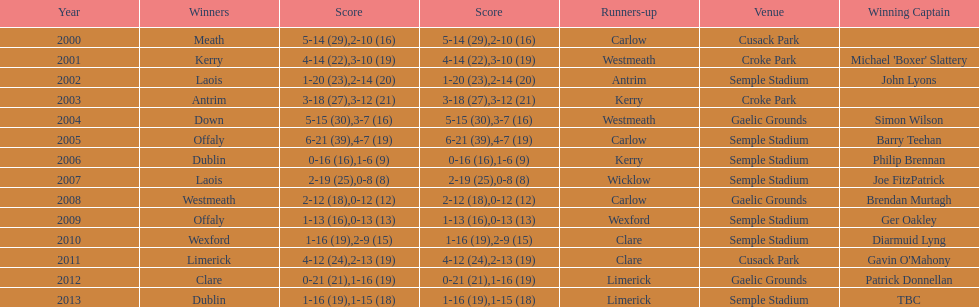Who was the first winner in 2013? Dublin. 